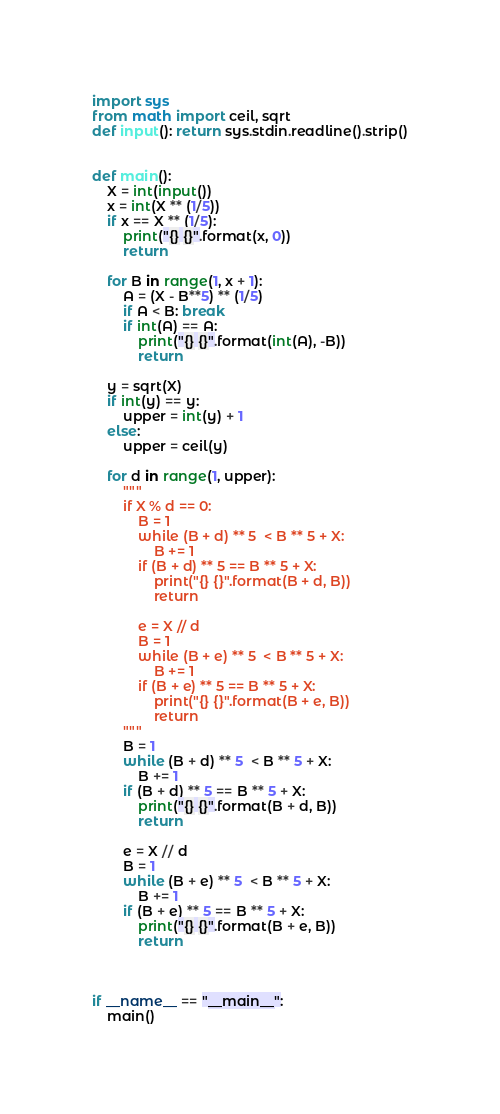Convert code to text. <code><loc_0><loc_0><loc_500><loc_500><_Python_>import sys
from math import ceil, sqrt
def input(): return sys.stdin.readline().strip()


def main():
    X = int(input())
    x = int(X ** (1/5))
    if x == X ** (1/5):
        print("{} {}".format(x, 0))
        return
    
    for B in range(1, x + 1):
        A = (X - B**5) ** (1/5)
        if A < B: break
        if int(A) == A:
            print("{} {}".format(int(A), -B))
            return
    
    y = sqrt(X)
    if int(y) == y:
        upper = int(y) + 1
    else:
        upper = ceil(y)

    for d in range(1, upper):
        """
        if X % d == 0:
            B = 1
            while (B + d) ** 5  < B ** 5 + X:
                B += 1
            if (B + d) ** 5 == B ** 5 + X:
                print("{} {}".format(B + d, B))
                return
            
            e = X // d
            B = 1
            while (B + e) ** 5  < B ** 5 + X:
                B += 1
            if (B + e) ** 5 == B ** 5 + X:
                print("{} {}".format(B + e, B))
                return
        """
        B = 1
        while (B + d) ** 5  < B ** 5 + X:
            B += 1
        if (B + d) ** 5 == B ** 5 + X:
            print("{} {}".format(B + d, B))
            return
        
        e = X // d
        B = 1
        while (B + e) ** 5  < B ** 5 + X:
            B += 1
        if (B + e) ** 5 == B ** 5 + X:
            print("{} {}".format(B + e, B))
            return



if __name__ == "__main__":
    main()
</code> 